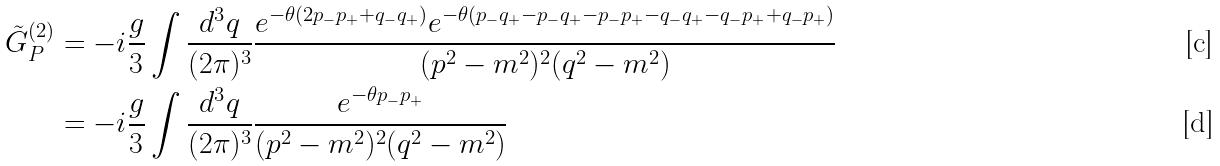<formula> <loc_0><loc_0><loc_500><loc_500>\tilde { G } _ { P } ^ { ( 2 ) } & = - i \frac { g } { 3 } \int \frac { d ^ { 3 } q } { ( 2 \pi ) ^ { 3 } } \frac { e ^ { - \theta ( 2 p _ { - } p _ { + } + q _ { - } q _ { + } ) } e ^ { - \theta ( p _ { - } q _ { + } - p _ { - } q _ { + } - p _ { - } p _ { + } - q _ { - } q _ { + } - q _ { - } p _ { + } + q _ { - } p _ { + } ) } } { ( p ^ { 2 } - m ^ { 2 } ) ^ { 2 } ( q ^ { 2 } - m ^ { 2 } ) } \\ & = - i \frac { g } { 3 } \int \frac { d ^ { 3 } q } { ( 2 \pi ) ^ { 3 } } \frac { e ^ { - \theta p _ { - } p _ { + } } } { ( p ^ { 2 } - m ^ { 2 } ) ^ { 2 } ( q ^ { 2 } - m ^ { 2 } ) }</formula> 